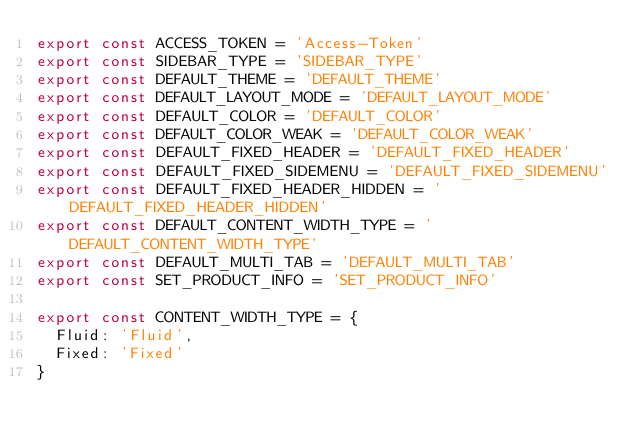Convert code to text. <code><loc_0><loc_0><loc_500><loc_500><_JavaScript_>export const ACCESS_TOKEN = 'Access-Token'
export const SIDEBAR_TYPE = 'SIDEBAR_TYPE'
export const DEFAULT_THEME = 'DEFAULT_THEME'
export const DEFAULT_LAYOUT_MODE = 'DEFAULT_LAYOUT_MODE'
export const DEFAULT_COLOR = 'DEFAULT_COLOR'
export const DEFAULT_COLOR_WEAK = 'DEFAULT_COLOR_WEAK'
export const DEFAULT_FIXED_HEADER = 'DEFAULT_FIXED_HEADER'
export const DEFAULT_FIXED_SIDEMENU = 'DEFAULT_FIXED_SIDEMENU'
export const DEFAULT_FIXED_HEADER_HIDDEN = 'DEFAULT_FIXED_HEADER_HIDDEN'
export const DEFAULT_CONTENT_WIDTH_TYPE = 'DEFAULT_CONTENT_WIDTH_TYPE'
export const DEFAULT_MULTI_TAB = 'DEFAULT_MULTI_TAB'
export const SET_PRODUCT_INFO = 'SET_PRODUCT_INFO'

export const CONTENT_WIDTH_TYPE = {
  Fluid: 'Fluid',
  Fixed: 'Fixed'
}
</code> 